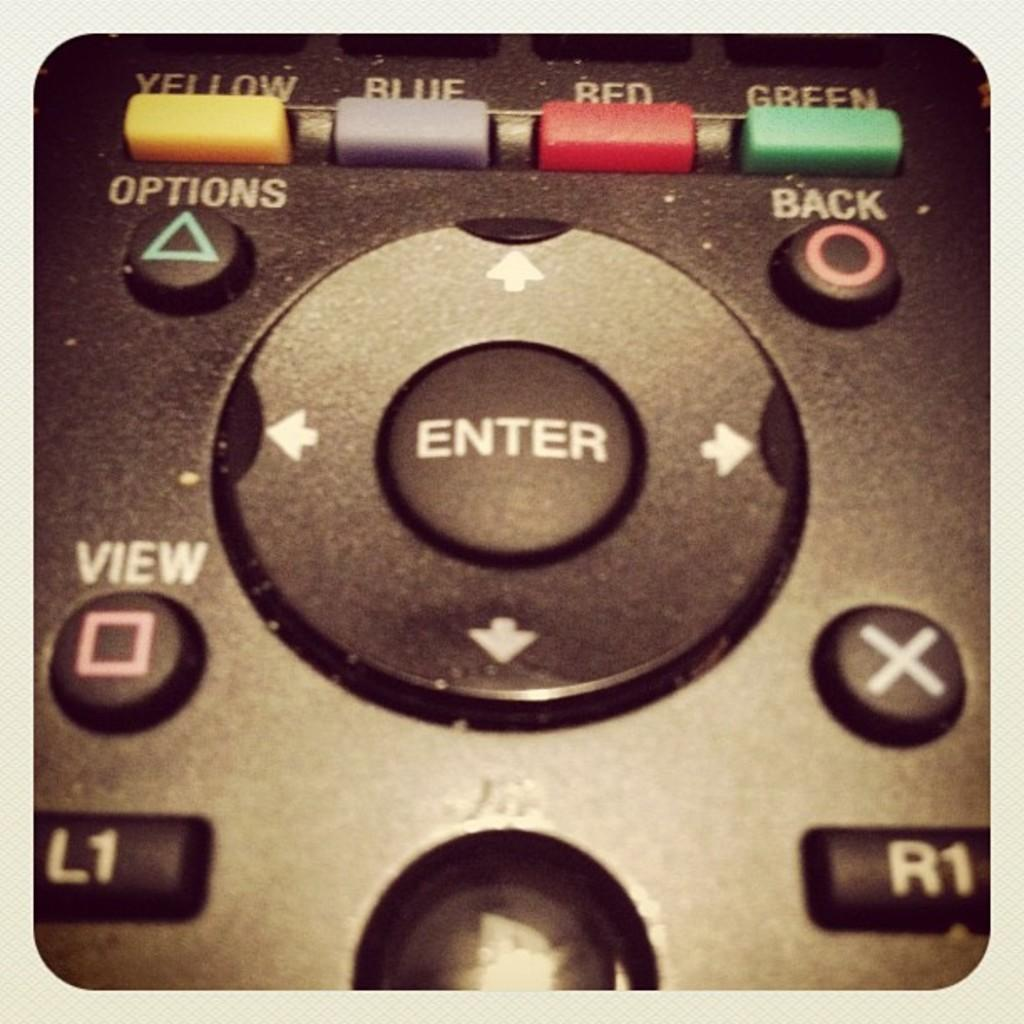<image>
Write a terse but informative summary of the picture. A remote control with yellow, blue, red, and green buttons across the top with the word "enter" written on a button in the center. 